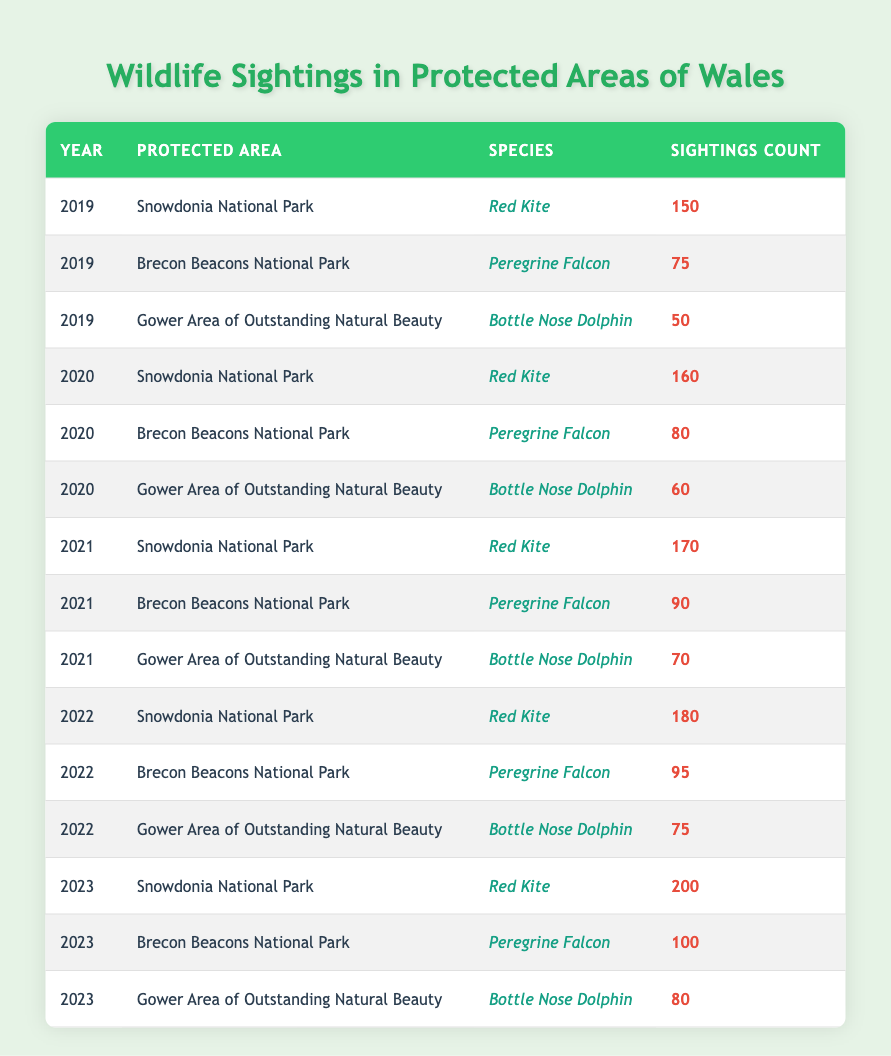What was the highest number of Red Kite sightings in Snowdonia National Park? The table shows that the number of Red Kite sightings in Snowdonia National Park increased over the years. The sightings were 150 in 2019, 160 in 2020, 170 in 2021, 180 in 2022, and 200 in 2023. The highest count is the last figure recorded in 2023, which is 200.
Answer: 200 How many sightings of Peregrine Falcon were recorded in 2021 in Brecon Beacons National Park? In 2021, the sightings of Peregrine Falcon in Brecon Beacons National Park is listed explicitly in the table as 90.
Answer: 90 What is the total number of Bottle Nose Dolphin sightings across all years in Gower Area of Outstanding Natural Beauty? The table provides the sighting counts for Bottle Nose Dolphin for each year: 50 in 2019, 60 in 2020, 70 in 2021, 75 in 2022, and 80 in 2023. Adding these numbers together gives us 50 + 60 + 70 + 75 + 80 = 335.
Answer: 335 Did the total sightings of Red Kite in Snowdonia National Park increase every year from 2019 to 2023? Looking at the table, the sightings of Red Kite in Snowdonia show the following counts: 150 in 2019, 160 in 2020, 170 in 2021, 180 in 2022, and 200 in 2023. Since all these numbers are greater than the previous year's count, the assertion is true.
Answer: Yes Which species had the highest count of sightings in 2023, and how many were there? In 2023, the table shows that Red Kite in Snowdonia had 200 sightings, Peregrine Falcon in Brecon Beacons had 100 sightings, and Bottle Nose Dolphin in Gower had 80 sightings. By comparing these numbers, Red Kite with 200 sightings had the highest count.
Answer: Red Kite, 200 What was the average number of sightings for Peregrine Falcon from 2019 to 2023? The Peregrine Falcon sightings in the Brecon Beacons were: 75 in 2019, 80 in 2020, 90 in 2021, 95 in 2022, and 100 in 2023. To find the average, we sum these values: 75 + 80 + 90 + 95 + 100 = 440, then divide by the number of years (5), which gives us 440 / 5 = 88.
Answer: 88 How many more Red Kite sightings were there in Snowdonia National Park in 2023 compared to 2019? The sightings for Red Kite in Snowdonia were 150 in 2019 and 200 in 2023, respectively. To find out how many more sightings there were, we subtract the earlier figure from the later one: 200 - 150 = 50.
Answer: 50 Were there more sightings of Bottle Nose Dolphin or Peregrine Falcon in 2022? From the table, we see that Bottle Nose Dolphin sightings in Gower were 75 while Peregrine Falcon sightings in Brecon Beacons were 95 in 2022. Since 95 is greater than 75, there were more Peregrine Falcon sightings.
Answer: Peregrine Falcon 